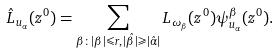Convert formula to latex. <formula><loc_0><loc_0><loc_500><loc_500>\hat { L } _ { u _ { \alpha } } ( z ^ { 0 } ) = \sum _ { \beta \colon | \beta | \leqslant r , \, | \hat { \beta } | \geqslant | \hat { \alpha } | } L _ { \omega _ { \beta } } ( z ^ { 0 } ) \psi ^ { \beta } _ { u _ { \alpha } } ( z ^ { 0 } ) .</formula> 